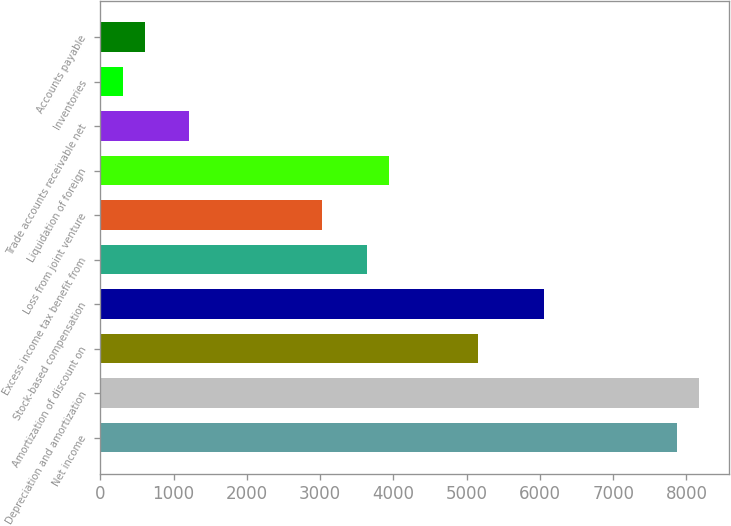Convert chart to OTSL. <chart><loc_0><loc_0><loc_500><loc_500><bar_chart><fcel>Net income<fcel>Depreciation and amortization<fcel>Amortization of discount on<fcel>Stock-based compensation<fcel>Excess income tax benefit from<fcel>Loss from joint venture<fcel>Liquidation of foreign<fcel>Trade accounts receivable net<fcel>Inventories<fcel>Accounts payable<nl><fcel>7873.8<fcel>8176.6<fcel>5148.6<fcel>6057<fcel>3634.6<fcel>3029<fcel>3937.4<fcel>1212.2<fcel>303.8<fcel>606.6<nl></chart> 